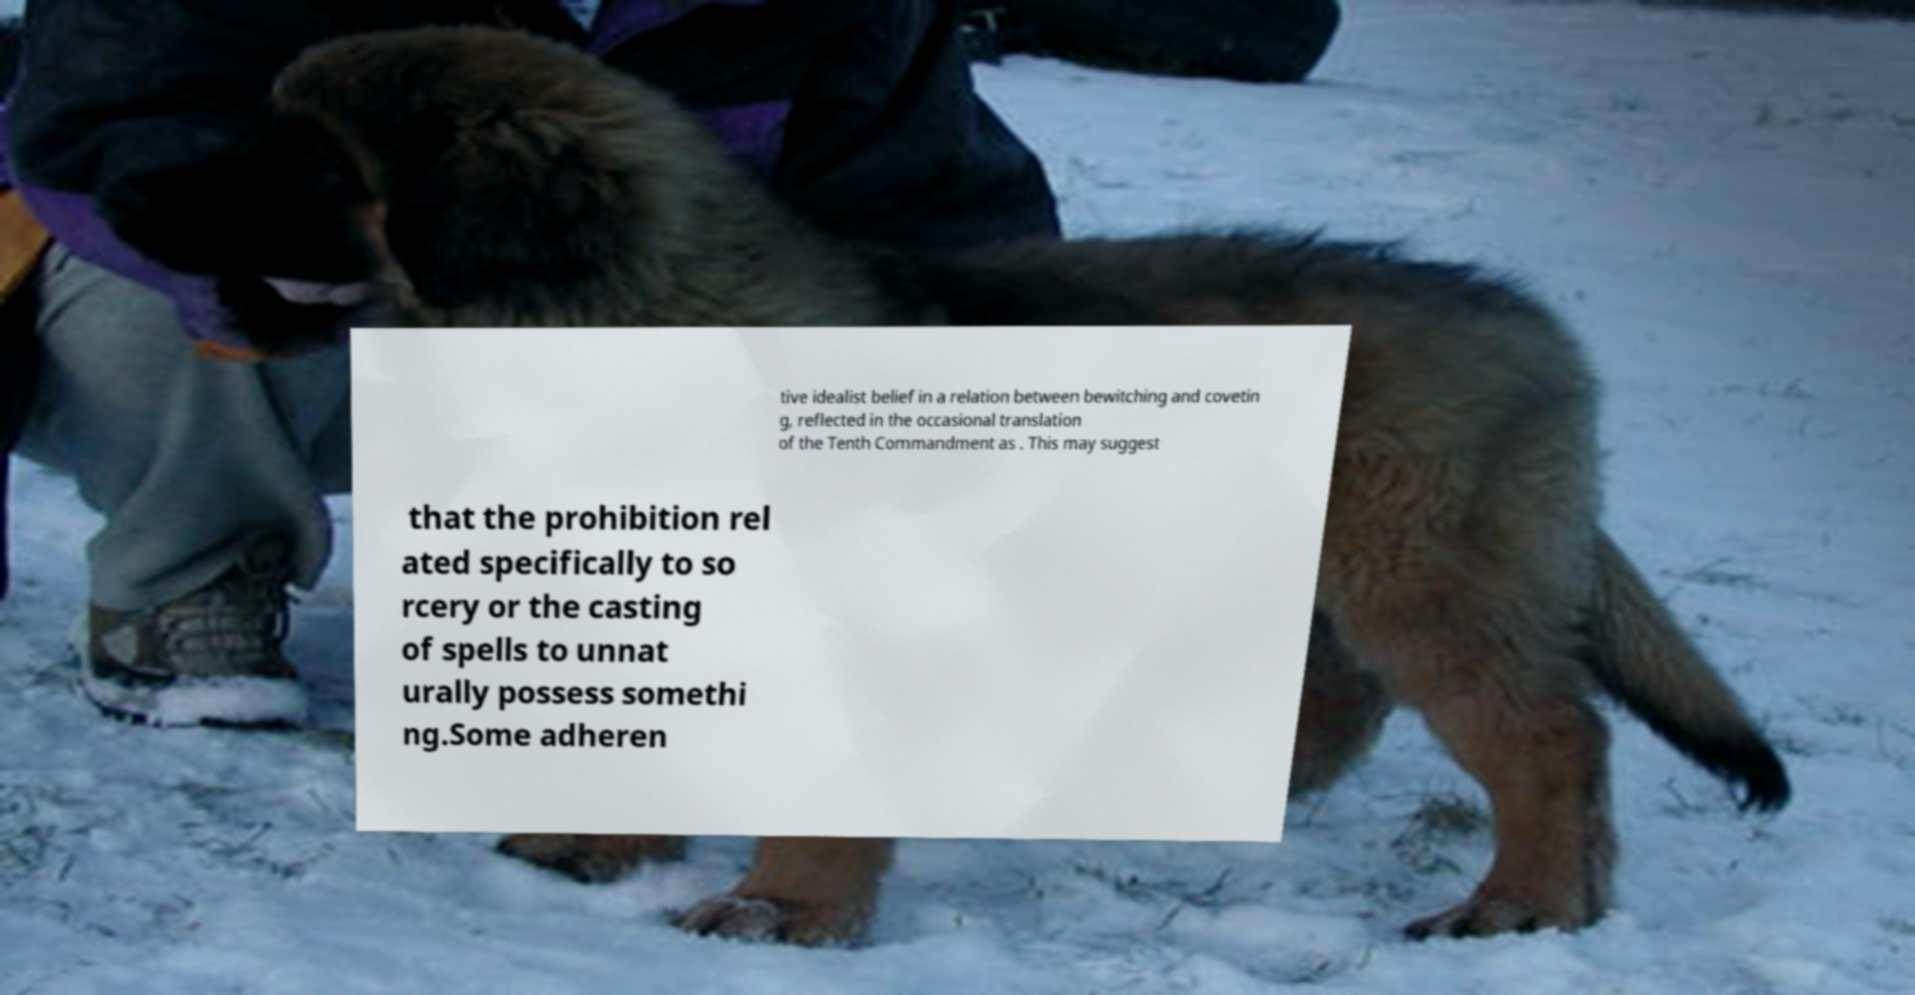For documentation purposes, I need the text within this image transcribed. Could you provide that? tive idealist belief in a relation between bewitching and covetin g, reflected in the occasional translation of the Tenth Commandment as . This may suggest that the prohibition rel ated specifically to so rcery or the casting of spells to unnat urally possess somethi ng.Some adheren 